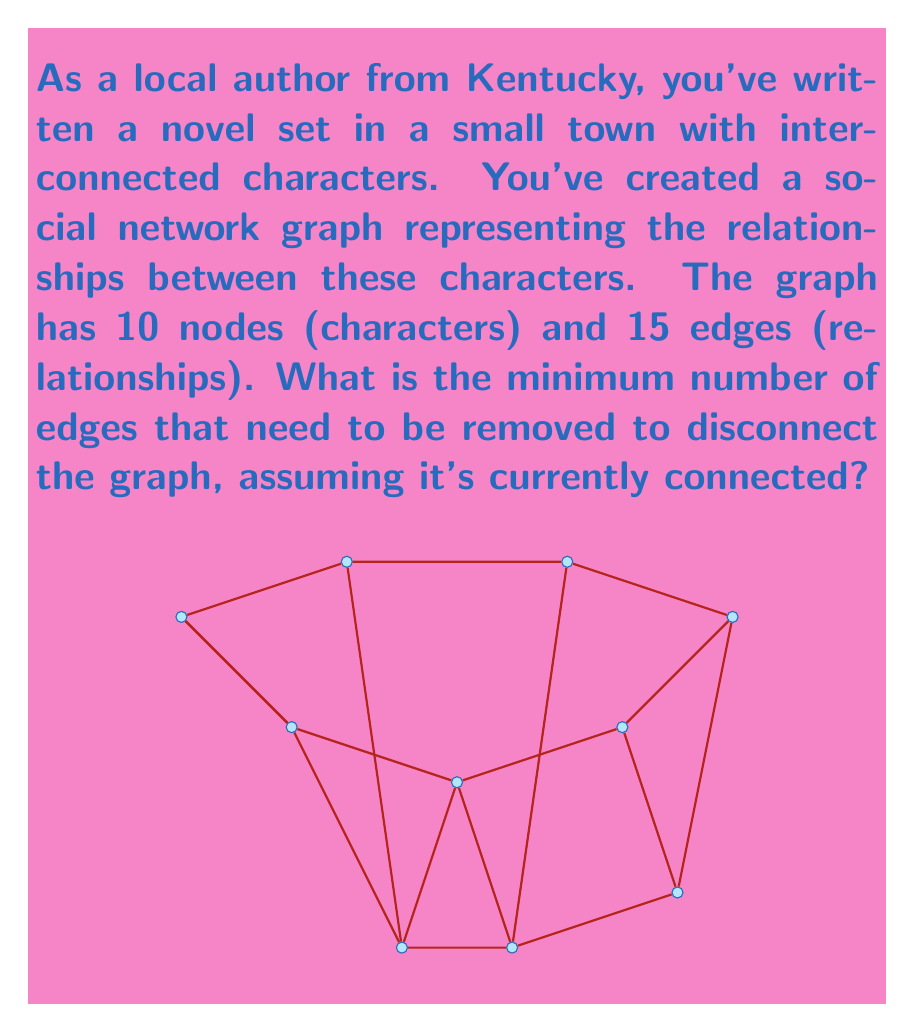Solve this math problem. To solve this problem, we need to understand the concept of edge connectivity in graph theory. The edge connectivity of a graph is the minimum number of edges that need to be removed to disconnect the graph. This is also known as the minimum cut of the graph.

Let's approach this step-by-step:

1) First, we need to understand what it means for a graph to be connected. A graph is connected if there is a path between every pair of vertices.

2) The question states that the graph is currently connected and has 10 nodes and 15 edges.

3) In a connected graph, the minimum number of edges required to keep all nodes connected is $(n-1)$, where $n$ is the number of nodes. This forms a tree structure known as a spanning tree.

4) In our case, with 10 nodes, the minimum number of edges to keep the graph connected is $10 - 1 = 9$.

5) The actual number of edges in our graph is 15, which is 6 more than the minimum required.

6) This means that we can remove up to 6 edges, and the graph will still remain connected.

7) Therefore, the minimum number of edges that need to be removed to disconnect the graph is the next edge after these 6, which is the 7th edge.

This number (7) represents the edge connectivity of the graph, also known as the minimum cut. Removing any 6 or fewer edges will keep the graph connected, but removing 7 edges will guarantee that the graph becomes disconnected.
Answer: 7 